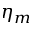<formula> <loc_0><loc_0><loc_500><loc_500>\eta _ { m }</formula> 